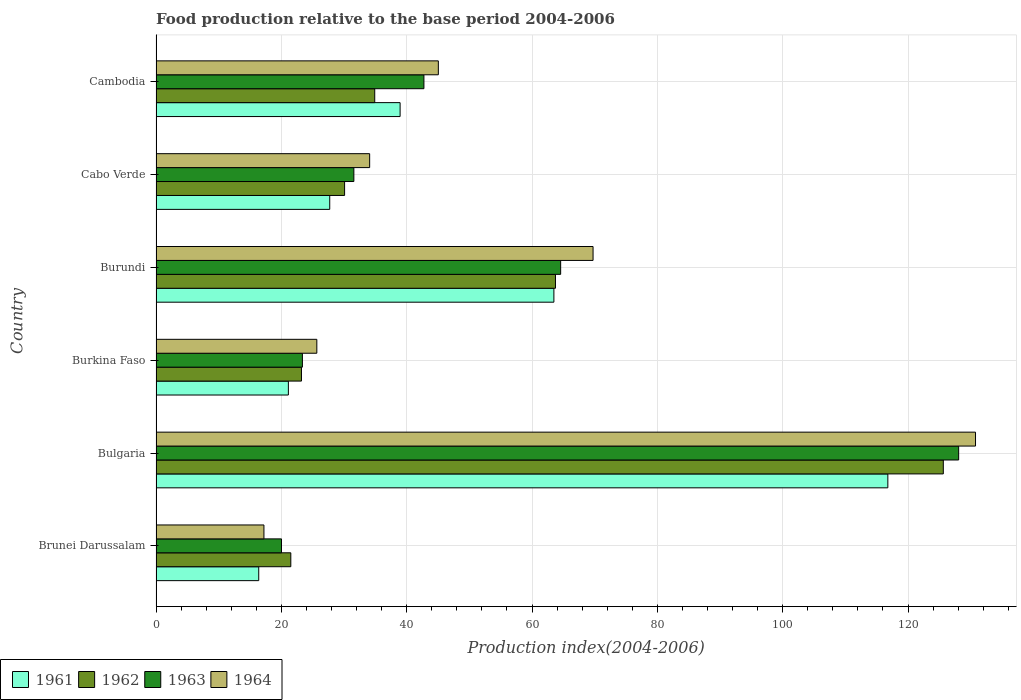How many different coloured bars are there?
Your response must be concise. 4. Are the number of bars on each tick of the Y-axis equal?
Your response must be concise. Yes. What is the label of the 6th group of bars from the top?
Offer a terse response. Brunei Darussalam. In how many cases, is the number of bars for a given country not equal to the number of legend labels?
Your answer should be very brief. 0. What is the food production index in 1961 in Cabo Verde?
Provide a short and direct response. 27.72. Across all countries, what is the maximum food production index in 1962?
Ensure brevity in your answer.  125.63. Across all countries, what is the minimum food production index in 1964?
Keep it short and to the point. 17.22. In which country was the food production index in 1962 minimum?
Keep it short and to the point. Brunei Darussalam. What is the total food production index in 1962 in the graph?
Offer a very short reply. 299.08. What is the difference between the food production index in 1962 in Brunei Darussalam and that in Cabo Verde?
Your answer should be very brief. -8.58. What is the difference between the food production index in 1964 in Burundi and the food production index in 1963 in Cambodia?
Ensure brevity in your answer.  26.99. What is the average food production index in 1963 per country?
Offer a terse response. 51.73. What is the difference between the food production index in 1964 and food production index in 1961 in Brunei Darussalam?
Provide a succinct answer. 0.83. In how many countries, is the food production index in 1963 greater than 96 ?
Provide a succinct answer. 1. What is the ratio of the food production index in 1964 in Burundi to that in Cambodia?
Provide a short and direct response. 1.55. Is the food production index in 1964 in Burkina Faso less than that in Cabo Verde?
Provide a succinct answer. Yes. What is the difference between the highest and the second highest food production index in 1964?
Your answer should be very brief. 61.03. What is the difference between the highest and the lowest food production index in 1963?
Offer a terse response. 108.06. Is it the case that in every country, the sum of the food production index in 1963 and food production index in 1961 is greater than the sum of food production index in 1964 and food production index in 1962?
Offer a terse response. No. What does the 4th bar from the bottom in Burundi represents?
Provide a short and direct response. 1964. How many bars are there?
Your answer should be very brief. 24. Are all the bars in the graph horizontal?
Your answer should be compact. Yes. Does the graph contain any zero values?
Provide a short and direct response. No. How many legend labels are there?
Offer a terse response. 4. How are the legend labels stacked?
Your answer should be very brief. Horizontal. What is the title of the graph?
Your answer should be very brief. Food production relative to the base period 2004-2006. What is the label or title of the X-axis?
Ensure brevity in your answer.  Production index(2004-2006). What is the Production index(2004-2006) in 1961 in Brunei Darussalam?
Make the answer very short. 16.39. What is the Production index(2004-2006) in 1962 in Brunei Darussalam?
Provide a short and direct response. 21.51. What is the Production index(2004-2006) in 1963 in Brunei Darussalam?
Make the answer very short. 20.02. What is the Production index(2004-2006) in 1964 in Brunei Darussalam?
Offer a terse response. 17.22. What is the Production index(2004-2006) of 1961 in Bulgaria?
Ensure brevity in your answer.  116.78. What is the Production index(2004-2006) of 1962 in Bulgaria?
Provide a succinct answer. 125.63. What is the Production index(2004-2006) of 1963 in Bulgaria?
Your response must be concise. 128.08. What is the Production index(2004-2006) in 1964 in Bulgaria?
Offer a terse response. 130.77. What is the Production index(2004-2006) in 1961 in Burkina Faso?
Offer a terse response. 21.12. What is the Production index(2004-2006) of 1962 in Burkina Faso?
Give a very brief answer. 23.21. What is the Production index(2004-2006) of 1963 in Burkina Faso?
Your answer should be very brief. 23.36. What is the Production index(2004-2006) of 1964 in Burkina Faso?
Your answer should be compact. 25.66. What is the Production index(2004-2006) of 1961 in Burundi?
Your answer should be very brief. 63.49. What is the Production index(2004-2006) of 1962 in Burundi?
Make the answer very short. 63.74. What is the Production index(2004-2006) of 1963 in Burundi?
Offer a terse response. 64.57. What is the Production index(2004-2006) in 1964 in Burundi?
Provide a succinct answer. 69.74. What is the Production index(2004-2006) in 1961 in Cabo Verde?
Offer a very short reply. 27.72. What is the Production index(2004-2006) of 1962 in Cabo Verde?
Keep it short and to the point. 30.09. What is the Production index(2004-2006) of 1963 in Cabo Verde?
Your response must be concise. 31.57. What is the Production index(2004-2006) in 1964 in Cabo Verde?
Ensure brevity in your answer.  34.09. What is the Production index(2004-2006) of 1961 in Cambodia?
Your answer should be compact. 38.95. What is the Production index(2004-2006) in 1962 in Cambodia?
Provide a succinct answer. 34.9. What is the Production index(2004-2006) in 1963 in Cambodia?
Ensure brevity in your answer.  42.75. What is the Production index(2004-2006) of 1964 in Cambodia?
Your answer should be very brief. 45.05. Across all countries, what is the maximum Production index(2004-2006) of 1961?
Ensure brevity in your answer.  116.78. Across all countries, what is the maximum Production index(2004-2006) of 1962?
Provide a short and direct response. 125.63. Across all countries, what is the maximum Production index(2004-2006) of 1963?
Offer a terse response. 128.08. Across all countries, what is the maximum Production index(2004-2006) of 1964?
Provide a succinct answer. 130.77. Across all countries, what is the minimum Production index(2004-2006) of 1961?
Offer a very short reply. 16.39. Across all countries, what is the minimum Production index(2004-2006) of 1962?
Make the answer very short. 21.51. Across all countries, what is the minimum Production index(2004-2006) in 1963?
Your response must be concise. 20.02. Across all countries, what is the minimum Production index(2004-2006) of 1964?
Your answer should be very brief. 17.22. What is the total Production index(2004-2006) in 1961 in the graph?
Provide a short and direct response. 284.45. What is the total Production index(2004-2006) of 1962 in the graph?
Give a very brief answer. 299.08. What is the total Production index(2004-2006) of 1963 in the graph?
Ensure brevity in your answer.  310.35. What is the total Production index(2004-2006) in 1964 in the graph?
Provide a succinct answer. 322.53. What is the difference between the Production index(2004-2006) of 1961 in Brunei Darussalam and that in Bulgaria?
Offer a terse response. -100.39. What is the difference between the Production index(2004-2006) of 1962 in Brunei Darussalam and that in Bulgaria?
Give a very brief answer. -104.12. What is the difference between the Production index(2004-2006) in 1963 in Brunei Darussalam and that in Bulgaria?
Provide a short and direct response. -108.06. What is the difference between the Production index(2004-2006) in 1964 in Brunei Darussalam and that in Bulgaria?
Make the answer very short. -113.55. What is the difference between the Production index(2004-2006) in 1961 in Brunei Darussalam and that in Burkina Faso?
Your response must be concise. -4.73. What is the difference between the Production index(2004-2006) in 1962 in Brunei Darussalam and that in Burkina Faso?
Make the answer very short. -1.7. What is the difference between the Production index(2004-2006) in 1963 in Brunei Darussalam and that in Burkina Faso?
Offer a terse response. -3.34. What is the difference between the Production index(2004-2006) in 1964 in Brunei Darussalam and that in Burkina Faso?
Keep it short and to the point. -8.44. What is the difference between the Production index(2004-2006) of 1961 in Brunei Darussalam and that in Burundi?
Offer a very short reply. -47.1. What is the difference between the Production index(2004-2006) in 1962 in Brunei Darussalam and that in Burundi?
Your answer should be very brief. -42.23. What is the difference between the Production index(2004-2006) in 1963 in Brunei Darussalam and that in Burundi?
Give a very brief answer. -44.55. What is the difference between the Production index(2004-2006) in 1964 in Brunei Darussalam and that in Burundi?
Give a very brief answer. -52.52. What is the difference between the Production index(2004-2006) in 1961 in Brunei Darussalam and that in Cabo Verde?
Provide a succinct answer. -11.33. What is the difference between the Production index(2004-2006) in 1962 in Brunei Darussalam and that in Cabo Verde?
Offer a very short reply. -8.58. What is the difference between the Production index(2004-2006) of 1963 in Brunei Darussalam and that in Cabo Verde?
Give a very brief answer. -11.55. What is the difference between the Production index(2004-2006) in 1964 in Brunei Darussalam and that in Cabo Verde?
Keep it short and to the point. -16.87. What is the difference between the Production index(2004-2006) in 1961 in Brunei Darussalam and that in Cambodia?
Your answer should be compact. -22.56. What is the difference between the Production index(2004-2006) in 1962 in Brunei Darussalam and that in Cambodia?
Give a very brief answer. -13.39. What is the difference between the Production index(2004-2006) of 1963 in Brunei Darussalam and that in Cambodia?
Your answer should be compact. -22.73. What is the difference between the Production index(2004-2006) in 1964 in Brunei Darussalam and that in Cambodia?
Provide a short and direct response. -27.83. What is the difference between the Production index(2004-2006) in 1961 in Bulgaria and that in Burkina Faso?
Your answer should be very brief. 95.66. What is the difference between the Production index(2004-2006) in 1962 in Bulgaria and that in Burkina Faso?
Your response must be concise. 102.42. What is the difference between the Production index(2004-2006) of 1963 in Bulgaria and that in Burkina Faso?
Your response must be concise. 104.72. What is the difference between the Production index(2004-2006) in 1964 in Bulgaria and that in Burkina Faso?
Give a very brief answer. 105.11. What is the difference between the Production index(2004-2006) in 1961 in Bulgaria and that in Burundi?
Your answer should be compact. 53.29. What is the difference between the Production index(2004-2006) of 1962 in Bulgaria and that in Burundi?
Ensure brevity in your answer.  61.89. What is the difference between the Production index(2004-2006) in 1963 in Bulgaria and that in Burundi?
Give a very brief answer. 63.51. What is the difference between the Production index(2004-2006) of 1964 in Bulgaria and that in Burundi?
Your answer should be compact. 61.03. What is the difference between the Production index(2004-2006) of 1961 in Bulgaria and that in Cabo Verde?
Your response must be concise. 89.06. What is the difference between the Production index(2004-2006) in 1962 in Bulgaria and that in Cabo Verde?
Ensure brevity in your answer.  95.54. What is the difference between the Production index(2004-2006) in 1963 in Bulgaria and that in Cabo Verde?
Your answer should be compact. 96.51. What is the difference between the Production index(2004-2006) in 1964 in Bulgaria and that in Cabo Verde?
Offer a terse response. 96.68. What is the difference between the Production index(2004-2006) of 1961 in Bulgaria and that in Cambodia?
Offer a terse response. 77.83. What is the difference between the Production index(2004-2006) of 1962 in Bulgaria and that in Cambodia?
Make the answer very short. 90.73. What is the difference between the Production index(2004-2006) of 1963 in Bulgaria and that in Cambodia?
Your response must be concise. 85.33. What is the difference between the Production index(2004-2006) of 1964 in Bulgaria and that in Cambodia?
Provide a succinct answer. 85.72. What is the difference between the Production index(2004-2006) in 1961 in Burkina Faso and that in Burundi?
Your answer should be compact. -42.37. What is the difference between the Production index(2004-2006) of 1962 in Burkina Faso and that in Burundi?
Your answer should be compact. -40.53. What is the difference between the Production index(2004-2006) in 1963 in Burkina Faso and that in Burundi?
Provide a succinct answer. -41.21. What is the difference between the Production index(2004-2006) in 1964 in Burkina Faso and that in Burundi?
Your answer should be compact. -44.08. What is the difference between the Production index(2004-2006) of 1962 in Burkina Faso and that in Cabo Verde?
Give a very brief answer. -6.88. What is the difference between the Production index(2004-2006) of 1963 in Burkina Faso and that in Cabo Verde?
Give a very brief answer. -8.21. What is the difference between the Production index(2004-2006) in 1964 in Burkina Faso and that in Cabo Verde?
Your answer should be compact. -8.43. What is the difference between the Production index(2004-2006) in 1961 in Burkina Faso and that in Cambodia?
Your answer should be very brief. -17.83. What is the difference between the Production index(2004-2006) in 1962 in Burkina Faso and that in Cambodia?
Provide a succinct answer. -11.69. What is the difference between the Production index(2004-2006) in 1963 in Burkina Faso and that in Cambodia?
Give a very brief answer. -19.39. What is the difference between the Production index(2004-2006) of 1964 in Burkina Faso and that in Cambodia?
Make the answer very short. -19.39. What is the difference between the Production index(2004-2006) in 1961 in Burundi and that in Cabo Verde?
Make the answer very short. 35.77. What is the difference between the Production index(2004-2006) in 1962 in Burundi and that in Cabo Verde?
Your response must be concise. 33.65. What is the difference between the Production index(2004-2006) in 1963 in Burundi and that in Cabo Verde?
Offer a very short reply. 33. What is the difference between the Production index(2004-2006) of 1964 in Burundi and that in Cabo Verde?
Make the answer very short. 35.65. What is the difference between the Production index(2004-2006) in 1961 in Burundi and that in Cambodia?
Your answer should be very brief. 24.54. What is the difference between the Production index(2004-2006) of 1962 in Burundi and that in Cambodia?
Your answer should be very brief. 28.84. What is the difference between the Production index(2004-2006) in 1963 in Burundi and that in Cambodia?
Offer a very short reply. 21.82. What is the difference between the Production index(2004-2006) of 1964 in Burundi and that in Cambodia?
Your answer should be compact. 24.69. What is the difference between the Production index(2004-2006) in 1961 in Cabo Verde and that in Cambodia?
Your answer should be compact. -11.23. What is the difference between the Production index(2004-2006) of 1962 in Cabo Verde and that in Cambodia?
Make the answer very short. -4.81. What is the difference between the Production index(2004-2006) in 1963 in Cabo Verde and that in Cambodia?
Your response must be concise. -11.18. What is the difference between the Production index(2004-2006) in 1964 in Cabo Verde and that in Cambodia?
Ensure brevity in your answer.  -10.96. What is the difference between the Production index(2004-2006) in 1961 in Brunei Darussalam and the Production index(2004-2006) in 1962 in Bulgaria?
Make the answer very short. -109.24. What is the difference between the Production index(2004-2006) in 1961 in Brunei Darussalam and the Production index(2004-2006) in 1963 in Bulgaria?
Make the answer very short. -111.69. What is the difference between the Production index(2004-2006) of 1961 in Brunei Darussalam and the Production index(2004-2006) of 1964 in Bulgaria?
Your answer should be compact. -114.38. What is the difference between the Production index(2004-2006) of 1962 in Brunei Darussalam and the Production index(2004-2006) of 1963 in Bulgaria?
Ensure brevity in your answer.  -106.57. What is the difference between the Production index(2004-2006) of 1962 in Brunei Darussalam and the Production index(2004-2006) of 1964 in Bulgaria?
Your response must be concise. -109.26. What is the difference between the Production index(2004-2006) in 1963 in Brunei Darussalam and the Production index(2004-2006) in 1964 in Bulgaria?
Your answer should be very brief. -110.75. What is the difference between the Production index(2004-2006) of 1961 in Brunei Darussalam and the Production index(2004-2006) of 1962 in Burkina Faso?
Ensure brevity in your answer.  -6.82. What is the difference between the Production index(2004-2006) in 1961 in Brunei Darussalam and the Production index(2004-2006) in 1963 in Burkina Faso?
Provide a succinct answer. -6.97. What is the difference between the Production index(2004-2006) of 1961 in Brunei Darussalam and the Production index(2004-2006) of 1964 in Burkina Faso?
Your answer should be very brief. -9.27. What is the difference between the Production index(2004-2006) in 1962 in Brunei Darussalam and the Production index(2004-2006) in 1963 in Burkina Faso?
Offer a very short reply. -1.85. What is the difference between the Production index(2004-2006) in 1962 in Brunei Darussalam and the Production index(2004-2006) in 1964 in Burkina Faso?
Offer a very short reply. -4.15. What is the difference between the Production index(2004-2006) in 1963 in Brunei Darussalam and the Production index(2004-2006) in 1964 in Burkina Faso?
Give a very brief answer. -5.64. What is the difference between the Production index(2004-2006) of 1961 in Brunei Darussalam and the Production index(2004-2006) of 1962 in Burundi?
Your response must be concise. -47.35. What is the difference between the Production index(2004-2006) in 1961 in Brunei Darussalam and the Production index(2004-2006) in 1963 in Burundi?
Provide a short and direct response. -48.18. What is the difference between the Production index(2004-2006) in 1961 in Brunei Darussalam and the Production index(2004-2006) in 1964 in Burundi?
Keep it short and to the point. -53.35. What is the difference between the Production index(2004-2006) in 1962 in Brunei Darussalam and the Production index(2004-2006) in 1963 in Burundi?
Keep it short and to the point. -43.06. What is the difference between the Production index(2004-2006) of 1962 in Brunei Darussalam and the Production index(2004-2006) of 1964 in Burundi?
Ensure brevity in your answer.  -48.23. What is the difference between the Production index(2004-2006) in 1963 in Brunei Darussalam and the Production index(2004-2006) in 1964 in Burundi?
Provide a succinct answer. -49.72. What is the difference between the Production index(2004-2006) of 1961 in Brunei Darussalam and the Production index(2004-2006) of 1962 in Cabo Verde?
Offer a terse response. -13.7. What is the difference between the Production index(2004-2006) in 1961 in Brunei Darussalam and the Production index(2004-2006) in 1963 in Cabo Verde?
Your answer should be very brief. -15.18. What is the difference between the Production index(2004-2006) in 1961 in Brunei Darussalam and the Production index(2004-2006) in 1964 in Cabo Verde?
Provide a succinct answer. -17.7. What is the difference between the Production index(2004-2006) of 1962 in Brunei Darussalam and the Production index(2004-2006) of 1963 in Cabo Verde?
Ensure brevity in your answer.  -10.06. What is the difference between the Production index(2004-2006) in 1962 in Brunei Darussalam and the Production index(2004-2006) in 1964 in Cabo Verde?
Keep it short and to the point. -12.58. What is the difference between the Production index(2004-2006) of 1963 in Brunei Darussalam and the Production index(2004-2006) of 1964 in Cabo Verde?
Keep it short and to the point. -14.07. What is the difference between the Production index(2004-2006) of 1961 in Brunei Darussalam and the Production index(2004-2006) of 1962 in Cambodia?
Provide a short and direct response. -18.51. What is the difference between the Production index(2004-2006) in 1961 in Brunei Darussalam and the Production index(2004-2006) in 1963 in Cambodia?
Give a very brief answer. -26.36. What is the difference between the Production index(2004-2006) of 1961 in Brunei Darussalam and the Production index(2004-2006) of 1964 in Cambodia?
Give a very brief answer. -28.66. What is the difference between the Production index(2004-2006) of 1962 in Brunei Darussalam and the Production index(2004-2006) of 1963 in Cambodia?
Offer a very short reply. -21.24. What is the difference between the Production index(2004-2006) of 1962 in Brunei Darussalam and the Production index(2004-2006) of 1964 in Cambodia?
Ensure brevity in your answer.  -23.54. What is the difference between the Production index(2004-2006) in 1963 in Brunei Darussalam and the Production index(2004-2006) in 1964 in Cambodia?
Make the answer very short. -25.03. What is the difference between the Production index(2004-2006) in 1961 in Bulgaria and the Production index(2004-2006) in 1962 in Burkina Faso?
Keep it short and to the point. 93.57. What is the difference between the Production index(2004-2006) in 1961 in Bulgaria and the Production index(2004-2006) in 1963 in Burkina Faso?
Your answer should be compact. 93.42. What is the difference between the Production index(2004-2006) in 1961 in Bulgaria and the Production index(2004-2006) in 1964 in Burkina Faso?
Give a very brief answer. 91.12. What is the difference between the Production index(2004-2006) in 1962 in Bulgaria and the Production index(2004-2006) in 1963 in Burkina Faso?
Your answer should be compact. 102.27. What is the difference between the Production index(2004-2006) of 1962 in Bulgaria and the Production index(2004-2006) of 1964 in Burkina Faso?
Your response must be concise. 99.97. What is the difference between the Production index(2004-2006) in 1963 in Bulgaria and the Production index(2004-2006) in 1964 in Burkina Faso?
Offer a very short reply. 102.42. What is the difference between the Production index(2004-2006) in 1961 in Bulgaria and the Production index(2004-2006) in 1962 in Burundi?
Offer a very short reply. 53.04. What is the difference between the Production index(2004-2006) in 1961 in Bulgaria and the Production index(2004-2006) in 1963 in Burundi?
Provide a succinct answer. 52.21. What is the difference between the Production index(2004-2006) of 1961 in Bulgaria and the Production index(2004-2006) of 1964 in Burundi?
Offer a terse response. 47.04. What is the difference between the Production index(2004-2006) in 1962 in Bulgaria and the Production index(2004-2006) in 1963 in Burundi?
Offer a very short reply. 61.06. What is the difference between the Production index(2004-2006) in 1962 in Bulgaria and the Production index(2004-2006) in 1964 in Burundi?
Your answer should be compact. 55.89. What is the difference between the Production index(2004-2006) in 1963 in Bulgaria and the Production index(2004-2006) in 1964 in Burundi?
Provide a succinct answer. 58.34. What is the difference between the Production index(2004-2006) in 1961 in Bulgaria and the Production index(2004-2006) in 1962 in Cabo Verde?
Ensure brevity in your answer.  86.69. What is the difference between the Production index(2004-2006) of 1961 in Bulgaria and the Production index(2004-2006) of 1963 in Cabo Verde?
Offer a very short reply. 85.21. What is the difference between the Production index(2004-2006) of 1961 in Bulgaria and the Production index(2004-2006) of 1964 in Cabo Verde?
Your answer should be compact. 82.69. What is the difference between the Production index(2004-2006) in 1962 in Bulgaria and the Production index(2004-2006) in 1963 in Cabo Verde?
Your answer should be very brief. 94.06. What is the difference between the Production index(2004-2006) of 1962 in Bulgaria and the Production index(2004-2006) of 1964 in Cabo Verde?
Offer a very short reply. 91.54. What is the difference between the Production index(2004-2006) in 1963 in Bulgaria and the Production index(2004-2006) in 1964 in Cabo Verde?
Your answer should be very brief. 93.99. What is the difference between the Production index(2004-2006) in 1961 in Bulgaria and the Production index(2004-2006) in 1962 in Cambodia?
Keep it short and to the point. 81.88. What is the difference between the Production index(2004-2006) in 1961 in Bulgaria and the Production index(2004-2006) in 1963 in Cambodia?
Offer a terse response. 74.03. What is the difference between the Production index(2004-2006) in 1961 in Bulgaria and the Production index(2004-2006) in 1964 in Cambodia?
Provide a short and direct response. 71.73. What is the difference between the Production index(2004-2006) of 1962 in Bulgaria and the Production index(2004-2006) of 1963 in Cambodia?
Provide a short and direct response. 82.88. What is the difference between the Production index(2004-2006) of 1962 in Bulgaria and the Production index(2004-2006) of 1964 in Cambodia?
Offer a very short reply. 80.58. What is the difference between the Production index(2004-2006) in 1963 in Bulgaria and the Production index(2004-2006) in 1964 in Cambodia?
Provide a short and direct response. 83.03. What is the difference between the Production index(2004-2006) of 1961 in Burkina Faso and the Production index(2004-2006) of 1962 in Burundi?
Provide a short and direct response. -42.62. What is the difference between the Production index(2004-2006) in 1961 in Burkina Faso and the Production index(2004-2006) in 1963 in Burundi?
Give a very brief answer. -43.45. What is the difference between the Production index(2004-2006) of 1961 in Burkina Faso and the Production index(2004-2006) of 1964 in Burundi?
Provide a succinct answer. -48.62. What is the difference between the Production index(2004-2006) in 1962 in Burkina Faso and the Production index(2004-2006) in 1963 in Burundi?
Ensure brevity in your answer.  -41.36. What is the difference between the Production index(2004-2006) of 1962 in Burkina Faso and the Production index(2004-2006) of 1964 in Burundi?
Give a very brief answer. -46.53. What is the difference between the Production index(2004-2006) in 1963 in Burkina Faso and the Production index(2004-2006) in 1964 in Burundi?
Ensure brevity in your answer.  -46.38. What is the difference between the Production index(2004-2006) in 1961 in Burkina Faso and the Production index(2004-2006) in 1962 in Cabo Verde?
Offer a very short reply. -8.97. What is the difference between the Production index(2004-2006) in 1961 in Burkina Faso and the Production index(2004-2006) in 1963 in Cabo Verde?
Offer a very short reply. -10.45. What is the difference between the Production index(2004-2006) in 1961 in Burkina Faso and the Production index(2004-2006) in 1964 in Cabo Verde?
Give a very brief answer. -12.97. What is the difference between the Production index(2004-2006) of 1962 in Burkina Faso and the Production index(2004-2006) of 1963 in Cabo Verde?
Offer a terse response. -8.36. What is the difference between the Production index(2004-2006) in 1962 in Burkina Faso and the Production index(2004-2006) in 1964 in Cabo Verde?
Offer a terse response. -10.88. What is the difference between the Production index(2004-2006) of 1963 in Burkina Faso and the Production index(2004-2006) of 1964 in Cabo Verde?
Your answer should be very brief. -10.73. What is the difference between the Production index(2004-2006) in 1961 in Burkina Faso and the Production index(2004-2006) in 1962 in Cambodia?
Your answer should be compact. -13.78. What is the difference between the Production index(2004-2006) of 1961 in Burkina Faso and the Production index(2004-2006) of 1963 in Cambodia?
Provide a succinct answer. -21.63. What is the difference between the Production index(2004-2006) in 1961 in Burkina Faso and the Production index(2004-2006) in 1964 in Cambodia?
Your answer should be compact. -23.93. What is the difference between the Production index(2004-2006) of 1962 in Burkina Faso and the Production index(2004-2006) of 1963 in Cambodia?
Your answer should be very brief. -19.54. What is the difference between the Production index(2004-2006) in 1962 in Burkina Faso and the Production index(2004-2006) in 1964 in Cambodia?
Keep it short and to the point. -21.84. What is the difference between the Production index(2004-2006) in 1963 in Burkina Faso and the Production index(2004-2006) in 1964 in Cambodia?
Offer a terse response. -21.69. What is the difference between the Production index(2004-2006) in 1961 in Burundi and the Production index(2004-2006) in 1962 in Cabo Verde?
Provide a short and direct response. 33.4. What is the difference between the Production index(2004-2006) of 1961 in Burundi and the Production index(2004-2006) of 1963 in Cabo Verde?
Offer a very short reply. 31.92. What is the difference between the Production index(2004-2006) of 1961 in Burundi and the Production index(2004-2006) of 1964 in Cabo Verde?
Your answer should be compact. 29.4. What is the difference between the Production index(2004-2006) in 1962 in Burundi and the Production index(2004-2006) in 1963 in Cabo Verde?
Offer a terse response. 32.17. What is the difference between the Production index(2004-2006) of 1962 in Burundi and the Production index(2004-2006) of 1964 in Cabo Verde?
Provide a short and direct response. 29.65. What is the difference between the Production index(2004-2006) of 1963 in Burundi and the Production index(2004-2006) of 1964 in Cabo Verde?
Offer a terse response. 30.48. What is the difference between the Production index(2004-2006) of 1961 in Burundi and the Production index(2004-2006) of 1962 in Cambodia?
Give a very brief answer. 28.59. What is the difference between the Production index(2004-2006) in 1961 in Burundi and the Production index(2004-2006) in 1963 in Cambodia?
Your answer should be compact. 20.74. What is the difference between the Production index(2004-2006) in 1961 in Burundi and the Production index(2004-2006) in 1964 in Cambodia?
Keep it short and to the point. 18.44. What is the difference between the Production index(2004-2006) in 1962 in Burundi and the Production index(2004-2006) in 1963 in Cambodia?
Provide a short and direct response. 20.99. What is the difference between the Production index(2004-2006) in 1962 in Burundi and the Production index(2004-2006) in 1964 in Cambodia?
Make the answer very short. 18.69. What is the difference between the Production index(2004-2006) in 1963 in Burundi and the Production index(2004-2006) in 1964 in Cambodia?
Offer a terse response. 19.52. What is the difference between the Production index(2004-2006) in 1961 in Cabo Verde and the Production index(2004-2006) in 1962 in Cambodia?
Offer a very short reply. -7.18. What is the difference between the Production index(2004-2006) of 1961 in Cabo Verde and the Production index(2004-2006) of 1963 in Cambodia?
Provide a succinct answer. -15.03. What is the difference between the Production index(2004-2006) in 1961 in Cabo Verde and the Production index(2004-2006) in 1964 in Cambodia?
Make the answer very short. -17.33. What is the difference between the Production index(2004-2006) of 1962 in Cabo Verde and the Production index(2004-2006) of 1963 in Cambodia?
Make the answer very short. -12.66. What is the difference between the Production index(2004-2006) of 1962 in Cabo Verde and the Production index(2004-2006) of 1964 in Cambodia?
Offer a terse response. -14.96. What is the difference between the Production index(2004-2006) in 1963 in Cabo Verde and the Production index(2004-2006) in 1964 in Cambodia?
Keep it short and to the point. -13.48. What is the average Production index(2004-2006) in 1961 per country?
Your answer should be compact. 47.41. What is the average Production index(2004-2006) in 1962 per country?
Make the answer very short. 49.85. What is the average Production index(2004-2006) in 1963 per country?
Keep it short and to the point. 51.73. What is the average Production index(2004-2006) in 1964 per country?
Your response must be concise. 53.76. What is the difference between the Production index(2004-2006) in 1961 and Production index(2004-2006) in 1962 in Brunei Darussalam?
Ensure brevity in your answer.  -5.12. What is the difference between the Production index(2004-2006) in 1961 and Production index(2004-2006) in 1963 in Brunei Darussalam?
Ensure brevity in your answer.  -3.63. What is the difference between the Production index(2004-2006) in 1961 and Production index(2004-2006) in 1964 in Brunei Darussalam?
Keep it short and to the point. -0.83. What is the difference between the Production index(2004-2006) in 1962 and Production index(2004-2006) in 1963 in Brunei Darussalam?
Provide a succinct answer. 1.49. What is the difference between the Production index(2004-2006) of 1962 and Production index(2004-2006) of 1964 in Brunei Darussalam?
Provide a short and direct response. 4.29. What is the difference between the Production index(2004-2006) of 1961 and Production index(2004-2006) of 1962 in Bulgaria?
Offer a very short reply. -8.85. What is the difference between the Production index(2004-2006) in 1961 and Production index(2004-2006) in 1963 in Bulgaria?
Provide a succinct answer. -11.3. What is the difference between the Production index(2004-2006) in 1961 and Production index(2004-2006) in 1964 in Bulgaria?
Provide a short and direct response. -13.99. What is the difference between the Production index(2004-2006) of 1962 and Production index(2004-2006) of 1963 in Bulgaria?
Your answer should be compact. -2.45. What is the difference between the Production index(2004-2006) of 1962 and Production index(2004-2006) of 1964 in Bulgaria?
Keep it short and to the point. -5.14. What is the difference between the Production index(2004-2006) of 1963 and Production index(2004-2006) of 1964 in Bulgaria?
Make the answer very short. -2.69. What is the difference between the Production index(2004-2006) of 1961 and Production index(2004-2006) of 1962 in Burkina Faso?
Make the answer very short. -2.09. What is the difference between the Production index(2004-2006) of 1961 and Production index(2004-2006) of 1963 in Burkina Faso?
Your answer should be compact. -2.24. What is the difference between the Production index(2004-2006) of 1961 and Production index(2004-2006) of 1964 in Burkina Faso?
Your answer should be compact. -4.54. What is the difference between the Production index(2004-2006) in 1962 and Production index(2004-2006) in 1963 in Burkina Faso?
Ensure brevity in your answer.  -0.15. What is the difference between the Production index(2004-2006) of 1962 and Production index(2004-2006) of 1964 in Burkina Faso?
Your answer should be compact. -2.45. What is the difference between the Production index(2004-2006) of 1963 and Production index(2004-2006) of 1964 in Burkina Faso?
Your response must be concise. -2.3. What is the difference between the Production index(2004-2006) of 1961 and Production index(2004-2006) of 1962 in Burundi?
Keep it short and to the point. -0.25. What is the difference between the Production index(2004-2006) of 1961 and Production index(2004-2006) of 1963 in Burundi?
Provide a succinct answer. -1.08. What is the difference between the Production index(2004-2006) in 1961 and Production index(2004-2006) in 1964 in Burundi?
Make the answer very short. -6.25. What is the difference between the Production index(2004-2006) in 1962 and Production index(2004-2006) in 1963 in Burundi?
Give a very brief answer. -0.83. What is the difference between the Production index(2004-2006) of 1963 and Production index(2004-2006) of 1964 in Burundi?
Keep it short and to the point. -5.17. What is the difference between the Production index(2004-2006) in 1961 and Production index(2004-2006) in 1962 in Cabo Verde?
Your answer should be compact. -2.37. What is the difference between the Production index(2004-2006) in 1961 and Production index(2004-2006) in 1963 in Cabo Verde?
Provide a short and direct response. -3.85. What is the difference between the Production index(2004-2006) of 1961 and Production index(2004-2006) of 1964 in Cabo Verde?
Give a very brief answer. -6.37. What is the difference between the Production index(2004-2006) of 1962 and Production index(2004-2006) of 1963 in Cabo Verde?
Offer a very short reply. -1.48. What is the difference between the Production index(2004-2006) in 1962 and Production index(2004-2006) in 1964 in Cabo Verde?
Your answer should be very brief. -4. What is the difference between the Production index(2004-2006) in 1963 and Production index(2004-2006) in 1964 in Cabo Verde?
Provide a succinct answer. -2.52. What is the difference between the Production index(2004-2006) in 1961 and Production index(2004-2006) in 1962 in Cambodia?
Your response must be concise. 4.05. What is the difference between the Production index(2004-2006) of 1961 and Production index(2004-2006) of 1964 in Cambodia?
Offer a very short reply. -6.1. What is the difference between the Production index(2004-2006) of 1962 and Production index(2004-2006) of 1963 in Cambodia?
Make the answer very short. -7.85. What is the difference between the Production index(2004-2006) of 1962 and Production index(2004-2006) of 1964 in Cambodia?
Keep it short and to the point. -10.15. What is the ratio of the Production index(2004-2006) in 1961 in Brunei Darussalam to that in Bulgaria?
Provide a short and direct response. 0.14. What is the ratio of the Production index(2004-2006) in 1962 in Brunei Darussalam to that in Bulgaria?
Offer a terse response. 0.17. What is the ratio of the Production index(2004-2006) in 1963 in Brunei Darussalam to that in Bulgaria?
Provide a short and direct response. 0.16. What is the ratio of the Production index(2004-2006) in 1964 in Brunei Darussalam to that in Bulgaria?
Provide a succinct answer. 0.13. What is the ratio of the Production index(2004-2006) in 1961 in Brunei Darussalam to that in Burkina Faso?
Provide a succinct answer. 0.78. What is the ratio of the Production index(2004-2006) of 1962 in Brunei Darussalam to that in Burkina Faso?
Make the answer very short. 0.93. What is the ratio of the Production index(2004-2006) of 1963 in Brunei Darussalam to that in Burkina Faso?
Your response must be concise. 0.86. What is the ratio of the Production index(2004-2006) in 1964 in Brunei Darussalam to that in Burkina Faso?
Make the answer very short. 0.67. What is the ratio of the Production index(2004-2006) in 1961 in Brunei Darussalam to that in Burundi?
Offer a very short reply. 0.26. What is the ratio of the Production index(2004-2006) in 1962 in Brunei Darussalam to that in Burundi?
Provide a succinct answer. 0.34. What is the ratio of the Production index(2004-2006) of 1963 in Brunei Darussalam to that in Burundi?
Provide a succinct answer. 0.31. What is the ratio of the Production index(2004-2006) of 1964 in Brunei Darussalam to that in Burundi?
Ensure brevity in your answer.  0.25. What is the ratio of the Production index(2004-2006) in 1961 in Brunei Darussalam to that in Cabo Verde?
Make the answer very short. 0.59. What is the ratio of the Production index(2004-2006) of 1962 in Brunei Darussalam to that in Cabo Verde?
Provide a succinct answer. 0.71. What is the ratio of the Production index(2004-2006) of 1963 in Brunei Darussalam to that in Cabo Verde?
Provide a short and direct response. 0.63. What is the ratio of the Production index(2004-2006) of 1964 in Brunei Darussalam to that in Cabo Verde?
Ensure brevity in your answer.  0.51. What is the ratio of the Production index(2004-2006) of 1961 in Brunei Darussalam to that in Cambodia?
Your response must be concise. 0.42. What is the ratio of the Production index(2004-2006) of 1962 in Brunei Darussalam to that in Cambodia?
Keep it short and to the point. 0.62. What is the ratio of the Production index(2004-2006) of 1963 in Brunei Darussalam to that in Cambodia?
Your answer should be very brief. 0.47. What is the ratio of the Production index(2004-2006) of 1964 in Brunei Darussalam to that in Cambodia?
Provide a succinct answer. 0.38. What is the ratio of the Production index(2004-2006) in 1961 in Bulgaria to that in Burkina Faso?
Keep it short and to the point. 5.53. What is the ratio of the Production index(2004-2006) in 1962 in Bulgaria to that in Burkina Faso?
Give a very brief answer. 5.41. What is the ratio of the Production index(2004-2006) of 1963 in Bulgaria to that in Burkina Faso?
Your response must be concise. 5.48. What is the ratio of the Production index(2004-2006) in 1964 in Bulgaria to that in Burkina Faso?
Your answer should be very brief. 5.1. What is the ratio of the Production index(2004-2006) of 1961 in Bulgaria to that in Burundi?
Ensure brevity in your answer.  1.84. What is the ratio of the Production index(2004-2006) in 1962 in Bulgaria to that in Burundi?
Your answer should be very brief. 1.97. What is the ratio of the Production index(2004-2006) of 1963 in Bulgaria to that in Burundi?
Offer a very short reply. 1.98. What is the ratio of the Production index(2004-2006) of 1964 in Bulgaria to that in Burundi?
Provide a succinct answer. 1.88. What is the ratio of the Production index(2004-2006) of 1961 in Bulgaria to that in Cabo Verde?
Your answer should be very brief. 4.21. What is the ratio of the Production index(2004-2006) in 1962 in Bulgaria to that in Cabo Verde?
Keep it short and to the point. 4.18. What is the ratio of the Production index(2004-2006) in 1963 in Bulgaria to that in Cabo Verde?
Your answer should be compact. 4.06. What is the ratio of the Production index(2004-2006) of 1964 in Bulgaria to that in Cabo Verde?
Give a very brief answer. 3.84. What is the ratio of the Production index(2004-2006) in 1961 in Bulgaria to that in Cambodia?
Provide a succinct answer. 3. What is the ratio of the Production index(2004-2006) in 1962 in Bulgaria to that in Cambodia?
Make the answer very short. 3.6. What is the ratio of the Production index(2004-2006) of 1963 in Bulgaria to that in Cambodia?
Offer a terse response. 3. What is the ratio of the Production index(2004-2006) in 1964 in Bulgaria to that in Cambodia?
Ensure brevity in your answer.  2.9. What is the ratio of the Production index(2004-2006) in 1961 in Burkina Faso to that in Burundi?
Keep it short and to the point. 0.33. What is the ratio of the Production index(2004-2006) of 1962 in Burkina Faso to that in Burundi?
Provide a succinct answer. 0.36. What is the ratio of the Production index(2004-2006) in 1963 in Burkina Faso to that in Burundi?
Offer a terse response. 0.36. What is the ratio of the Production index(2004-2006) of 1964 in Burkina Faso to that in Burundi?
Offer a very short reply. 0.37. What is the ratio of the Production index(2004-2006) in 1961 in Burkina Faso to that in Cabo Verde?
Your answer should be compact. 0.76. What is the ratio of the Production index(2004-2006) of 1962 in Burkina Faso to that in Cabo Verde?
Your answer should be very brief. 0.77. What is the ratio of the Production index(2004-2006) of 1963 in Burkina Faso to that in Cabo Verde?
Keep it short and to the point. 0.74. What is the ratio of the Production index(2004-2006) in 1964 in Burkina Faso to that in Cabo Verde?
Your response must be concise. 0.75. What is the ratio of the Production index(2004-2006) of 1961 in Burkina Faso to that in Cambodia?
Offer a very short reply. 0.54. What is the ratio of the Production index(2004-2006) of 1962 in Burkina Faso to that in Cambodia?
Your response must be concise. 0.67. What is the ratio of the Production index(2004-2006) of 1963 in Burkina Faso to that in Cambodia?
Your answer should be very brief. 0.55. What is the ratio of the Production index(2004-2006) of 1964 in Burkina Faso to that in Cambodia?
Your response must be concise. 0.57. What is the ratio of the Production index(2004-2006) in 1961 in Burundi to that in Cabo Verde?
Offer a terse response. 2.29. What is the ratio of the Production index(2004-2006) of 1962 in Burundi to that in Cabo Verde?
Provide a succinct answer. 2.12. What is the ratio of the Production index(2004-2006) of 1963 in Burundi to that in Cabo Verde?
Your answer should be very brief. 2.05. What is the ratio of the Production index(2004-2006) of 1964 in Burundi to that in Cabo Verde?
Your answer should be very brief. 2.05. What is the ratio of the Production index(2004-2006) in 1961 in Burundi to that in Cambodia?
Offer a very short reply. 1.63. What is the ratio of the Production index(2004-2006) of 1962 in Burundi to that in Cambodia?
Keep it short and to the point. 1.83. What is the ratio of the Production index(2004-2006) of 1963 in Burundi to that in Cambodia?
Provide a short and direct response. 1.51. What is the ratio of the Production index(2004-2006) in 1964 in Burundi to that in Cambodia?
Make the answer very short. 1.55. What is the ratio of the Production index(2004-2006) in 1961 in Cabo Verde to that in Cambodia?
Provide a short and direct response. 0.71. What is the ratio of the Production index(2004-2006) of 1962 in Cabo Verde to that in Cambodia?
Offer a terse response. 0.86. What is the ratio of the Production index(2004-2006) in 1963 in Cabo Verde to that in Cambodia?
Provide a succinct answer. 0.74. What is the ratio of the Production index(2004-2006) in 1964 in Cabo Verde to that in Cambodia?
Provide a succinct answer. 0.76. What is the difference between the highest and the second highest Production index(2004-2006) of 1961?
Provide a short and direct response. 53.29. What is the difference between the highest and the second highest Production index(2004-2006) in 1962?
Your answer should be compact. 61.89. What is the difference between the highest and the second highest Production index(2004-2006) in 1963?
Offer a very short reply. 63.51. What is the difference between the highest and the second highest Production index(2004-2006) of 1964?
Offer a terse response. 61.03. What is the difference between the highest and the lowest Production index(2004-2006) in 1961?
Keep it short and to the point. 100.39. What is the difference between the highest and the lowest Production index(2004-2006) of 1962?
Make the answer very short. 104.12. What is the difference between the highest and the lowest Production index(2004-2006) of 1963?
Provide a short and direct response. 108.06. What is the difference between the highest and the lowest Production index(2004-2006) in 1964?
Keep it short and to the point. 113.55. 